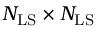<formula> <loc_0><loc_0><loc_500><loc_500>N _ { L S } \times N _ { L S }</formula> 